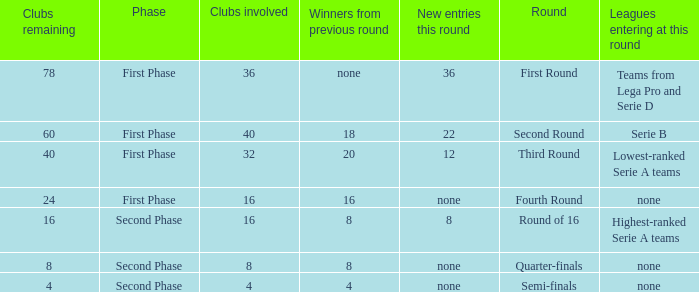Give me the full table as a dictionary. {'header': ['Clubs remaining', 'Phase', 'Clubs involved', 'Winners from previous round', 'New entries this round', 'Round', 'Leagues entering at this round'], 'rows': [['78', 'First Phase', '36', 'none', '36', 'First Round', 'Teams from Lega Pro and Serie D'], ['60', 'First Phase', '40', '18', '22', 'Second Round', 'Serie B'], ['40', 'First Phase', '32', '20', '12', 'Third Round', 'Lowest-ranked Serie A teams'], ['24', 'First Phase', '16', '16', 'none', 'Fourth Round', 'none'], ['16', 'Second Phase', '16', '8', '8', 'Round of 16', 'Highest-ranked Serie A teams'], ['8', 'Second Phase', '8', '8', 'none', 'Quarter-finals', 'none'], ['4', 'Second Phase', '4', '4', 'none', 'Semi-finals', 'none']]} The new entries this round was shown to be 12, in which phase would you find this? First Phase. 